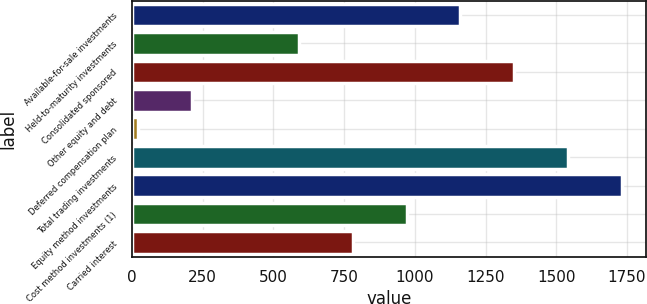Convert chart. <chart><loc_0><loc_0><loc_500><loc_500><bar_chart><fcel>Available-for-sale investments<fcel>Held-to-maturity investments<fcel>Consolidated sponsored<fcel>Other equity and debt<fcel>Deferred compensation plan<fcel>Total trading investments<fcel>Equity method investments<fcel>Cost method investments (1)<fcel>Carried interest<nl><fcel>1161<fcel>591<fcel>1351<fcel>211<fcel>21<fcel>1541<fcel>1731<fcel>971<fcel>781<nl></chart> 